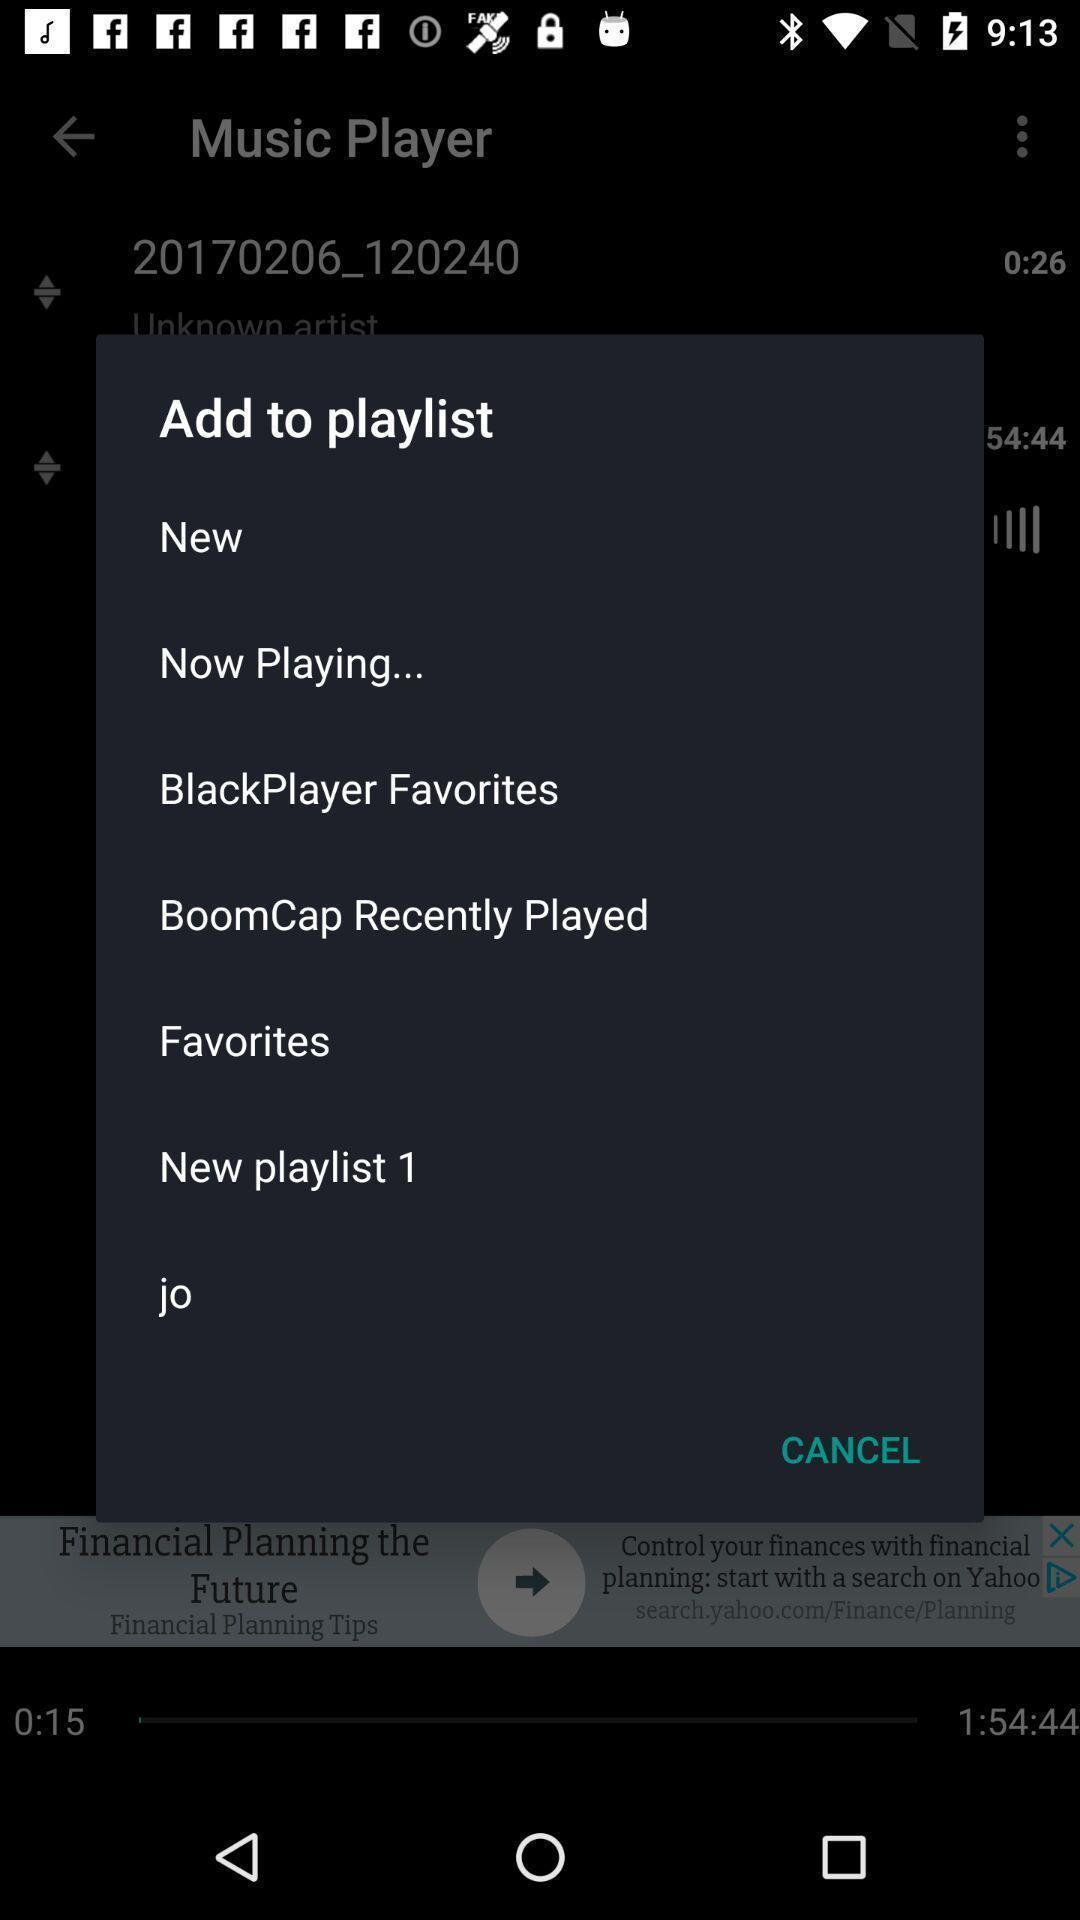What is the overall content of this screenshot? Pop up to add songs to playlist. 